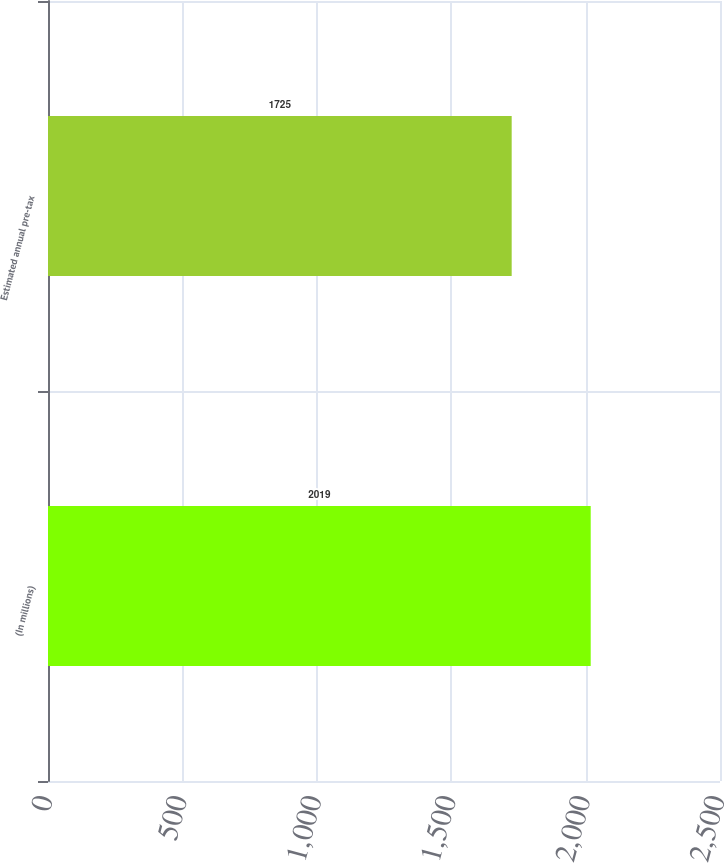<chart> <loc_0><loc_0><loc_500><loc_500><bar_chart><fcel>(In millions)<fcel>Estimated annual pre-tax<nl><fcel>2019<fcel>1725<nl></chart> 